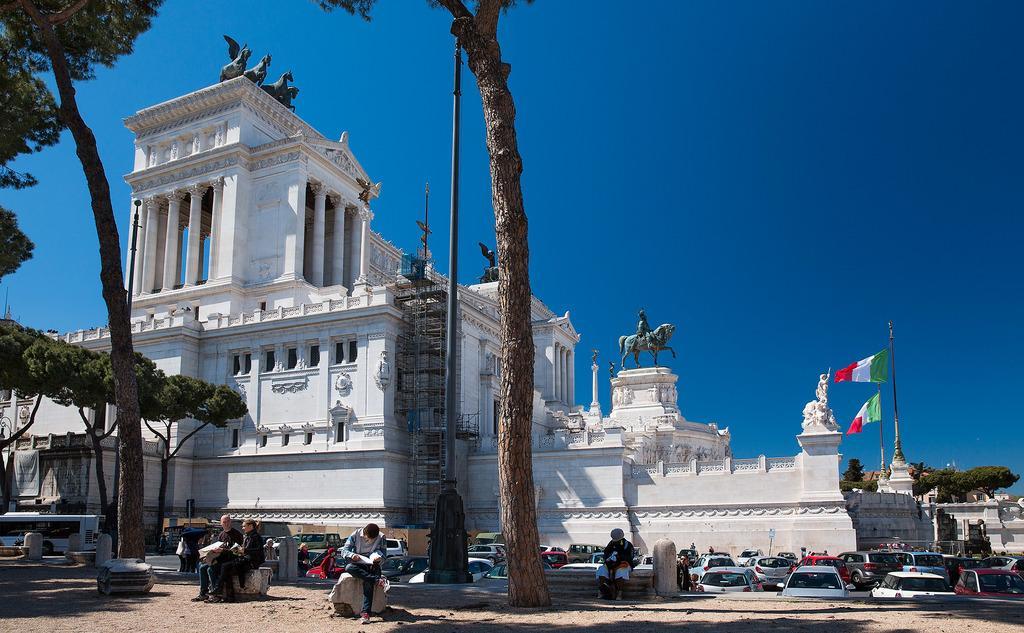Can you describe this image briefly? In the foreground of the picture there are people, trees, soil and cars. In the center of the picture there is a building, on the building there are sculpture and flag. On the right, in the background there are trees. Sky is clear and it is sunny. 